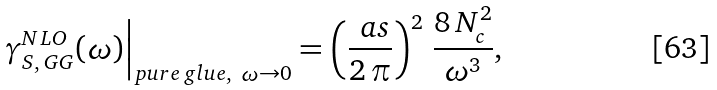<formula> <loc_0><loc_0><loc_500><loc_500>\gamma _ { S , \, G G } ^ { N L O } ( \omega ) \Big | _ { p u r e \, g l u e , \ \omega \to 0 } = \left ( \frac { \ a s } { 2 \, \pi } \right ) ^ { 2 } \, \frac { 8 \, N _ { c } ^ { 2 } } { \omega ^ { 3 } } ,</formula> 